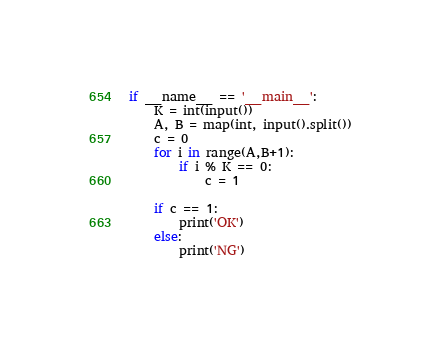<code> <loc_0><loc_0><loc_500><loc_500><_Python_>if __name__ == '__main__':
	K = int(input())
	A, B = map(int, input().split())
	c = 0
	for i in range(A,B+1):
		if i % K == 0:
			c = 1

	if c == 1:
		print('OK')
	else:
		print('NG')</code> 